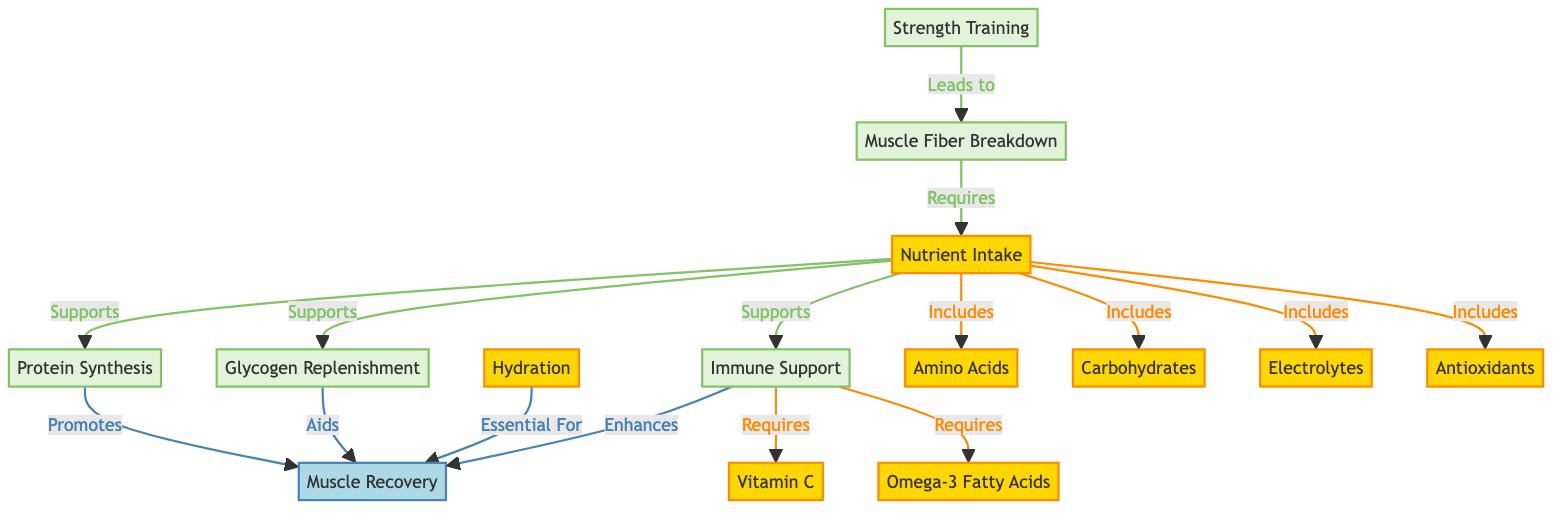What is the first node in the diagram? The first node is "Strength Training," indicating the starting point of the process.
Answer: Strength Training How many nutrient categories are included in the diagram? There are five nutrient categories depicted in the diagram: amino acids, carbohydrates, electrolytes, antioxidants, and omega-3 fatty acids.
Answer: Five What supports muscle recovery according to the diagram? Muscle recovery is supported by protein synthesis, glycogen replenishment, hydration, and immune support.
Answer: Protein synthesis, glycogen replenishment, hydration, immune support Which nutrient is specifically required for immune support? Vitamin C is required for immune support, as indicated in the diagram that links immune support to vitamin C.
Answer: Vitamin C What leads to muscle fiber breakdown? The process of strength training leads to muscle fiber breakdown, as depicted by the arrow connecting these two nodes.
Answer: Strength Training What role do carbohydrates play in recovery? Carbohydrates aid in recovery by replenishing glycogen stores, as illustrated in the diagram linking nutrient intake to glycogen replenishment.
Answer: Aids Glycogen Replenishment Which nutrient supports both protein synthesis and glycogen replenishment? Nutrient intake supports both protein synthesis and glycogen replenishment according to the diagram, as it links to both processes.
Answer: Nutrient Intake How many processes are shown leading to muscle recovery? There are four processes shown leading to muscle recovery: protein synthesis, glycogen replenishment, hydration, and immune support.
Answer: Four What type of nutrients are depicted in orange? The nutrients depicted in orange are categorized under the label "nutrient," specifically highlighting their roles in recovery and muscle repair.
Answer: Nutrient 